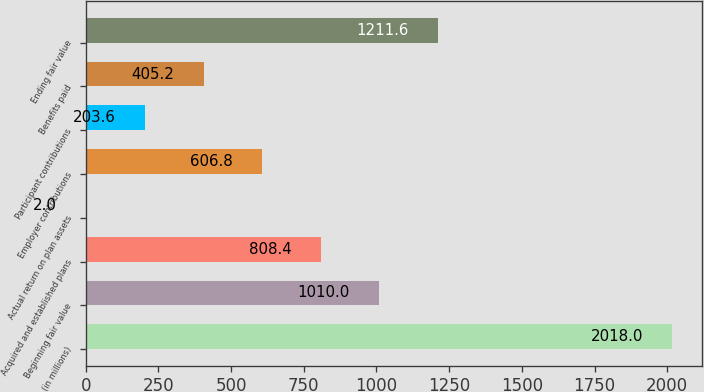Convert chart. <chart><loc_0><loc_0><loc_500><loc_500><bar_chart><fcel>(in millions)<fcel>Beginning fair value<fcel>Acquired and established plans<fcel>Actual return on plan assets<fcel>Employer contributions<fcel>Participant contributions<fcel>Benefits paid<fcel>Ending fair value<nl><fcel>2018<fcel>1010<fcel>808.4<fcel>2<fcel>606.8<fcel>203.6<fcel>405.2<fcel>1211.6<nl></chart> 